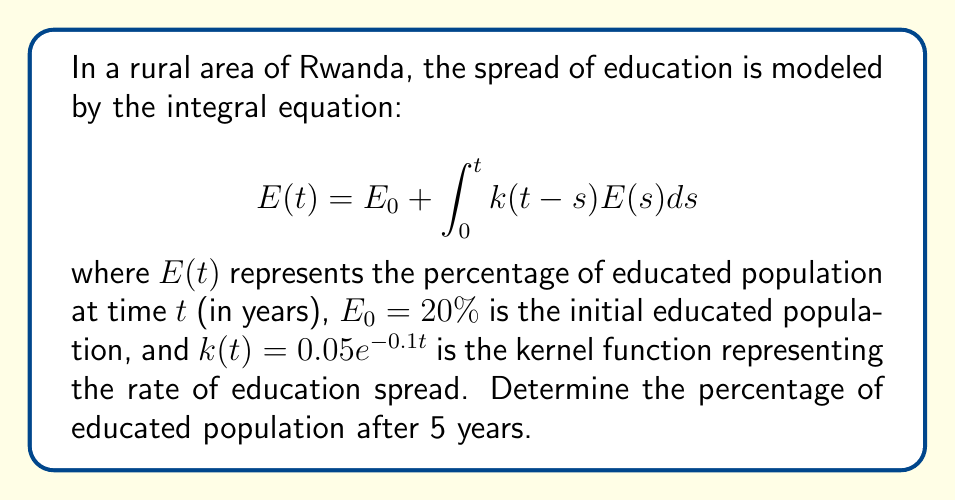Can you answer this question? To solve this integral equation, we'll use the Laplace transform method:

1) Take the Laplace transform of both sides:
   $$\mathcal{L}\{E(t)\} = \mathcal{L}\{E_0\} + \mathcal{L}\{\int_0^t k(t-s)E(s)ds\}$$

2) Using the properties of Laplace transform:
   $$\hat{E}(p) = \frac{E_0}{p} + \hat{K}(p)\hat{E}(p)$$
   where $\hat{E}(p)$ is the Laplace transform of $E(t)$ and $\hat{K}(p)$ is the Laplace transform of $k(t)$.

3) Calculate $\hat{K}(p)$:
   $$\hat{K}(p) = \mathcal{L}\{0.05e^{-0.1t}\} = \frac{0.05}{p+0.1}$$

4) Substitute and solve for $\hat{E}(p)$:
   $$\hat{E}(p) = \frac{E_0}{p} + \frac{0.05}{p+0.1}\hat{E}(p)$$
   $$\hat{E}(p)(1 - \frac{0.05}{p+0.1}) = \frac{E_0}{p}$$
   $$\hat{E}(p) = \frac{E_0}{p} \cdot \frac{p+0.1}{p+0.05}$$

5) Take the inverse Laplace transform:
   $$E(t) = E_0 + E_0(1 - e^{-0.05t})$$

6) Substitute $E_0 = 20\%$ and $t = 5$:
   $$E(5) = 20\% + 20\%(1 - e^{-0.05 \cdot 5})$$
   $$E(5) = 20\% + 20\%(1 - e^{-0.25})$$
   $$E(5) \approx 20\% + 20\%(0.2212) \approx 24.42\%$$

Therefore, after 5 years, approximately 24.42% of the population will be educated.
Answer: 24.42% 